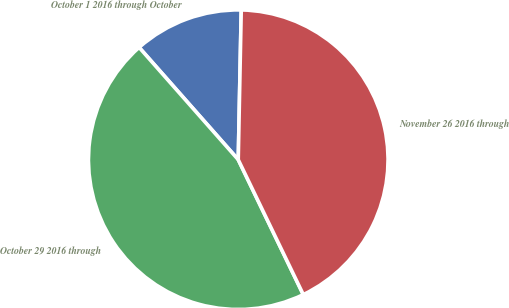Convert chart to OTSL. <chart><loc_0><loc_0><loc_500><loc_500><pie_chart><fcel>October 1 2016 through October<fcel>October 29 2016 through<fcel>November 26 2016 through<nl><fcel>11.83%<fcel>45.64%<fcel>42.53%<nl></chart> 